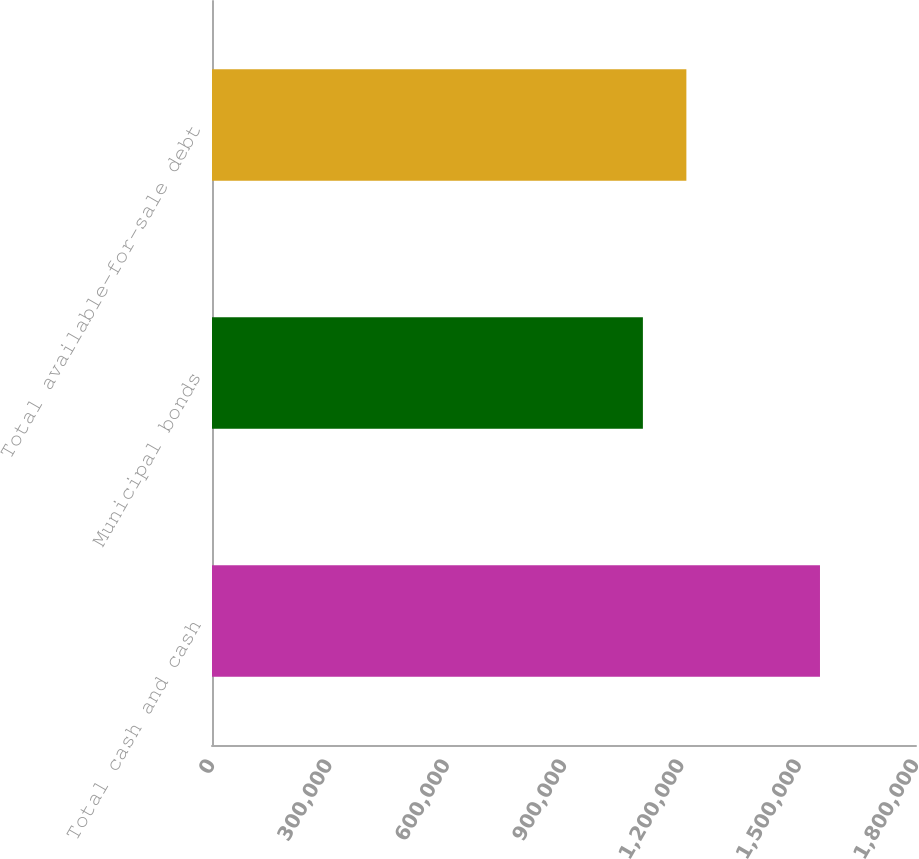Convert chart to OTSL. <chart><loc_0><loc_0><loc_500><loc_500><bar_chart><fcel>Total cash and cash<fcel>Municipal bonds<fcel>Total available-for-sale debt<nl><fcel>1.5545e+06<fcel>1.10172e+06<fcel>1.21288e+06<nl></chart> 